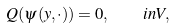<formula> <loc_0><loc_0><loc_500><loc_500>Q ( \psi ( y , \cdot ) ) = 0 , \quad i n V ,</formula> 